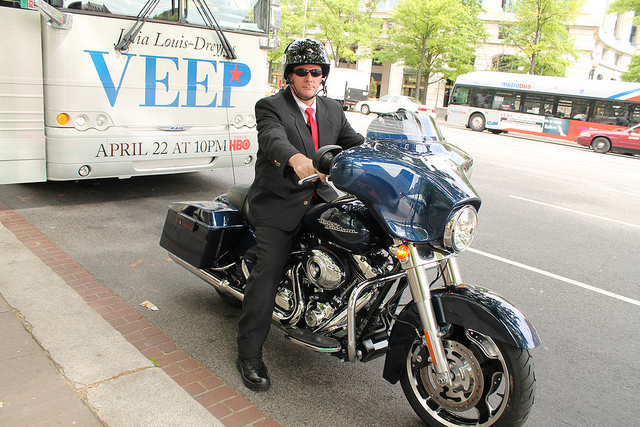Please identify all text content in this image. VEEP APRIL 22 AT 10PM HBO Louis ia 